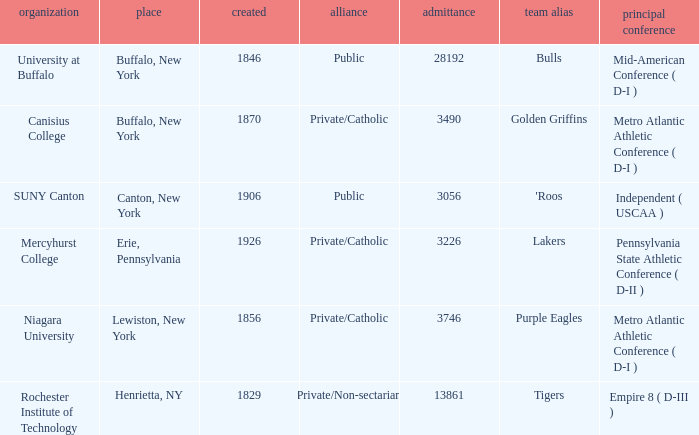What kind of school is Canton, New York? Public. 